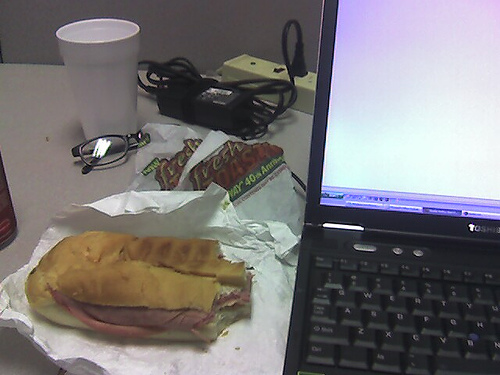What type of meal is on the desk? It looks like a deli sandwich, possibly with ham or other cold cuts, paired with a bag of chips and a white plastic cup that might contain a drink. 